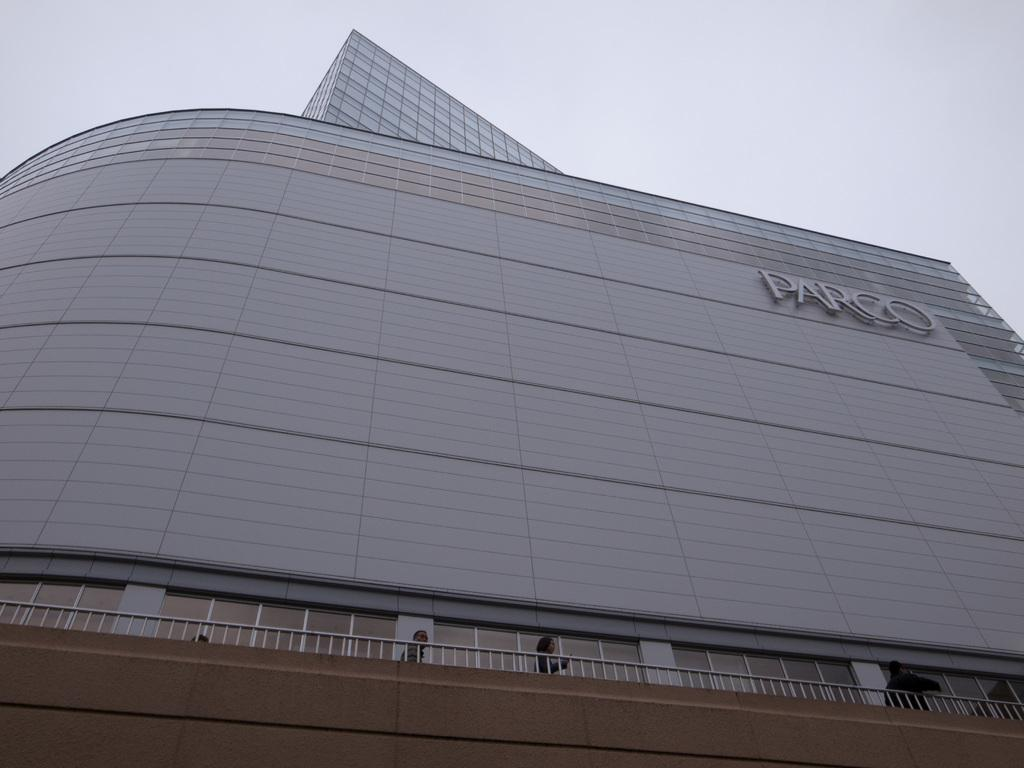What are the people in the image doing? The group of people is standing on the ground in the image. What can be seen near the people? There is metal railing in the image. What is visible in the background of the image? There is a building and the sky in the background of the image. Can you describe the building in the image? The building has some text on it. What type of coal is being used to fuel the anger in the image? There is no coal or anger present in the image; it features a group of people standing near metal railing with a building and the sky in the background. 